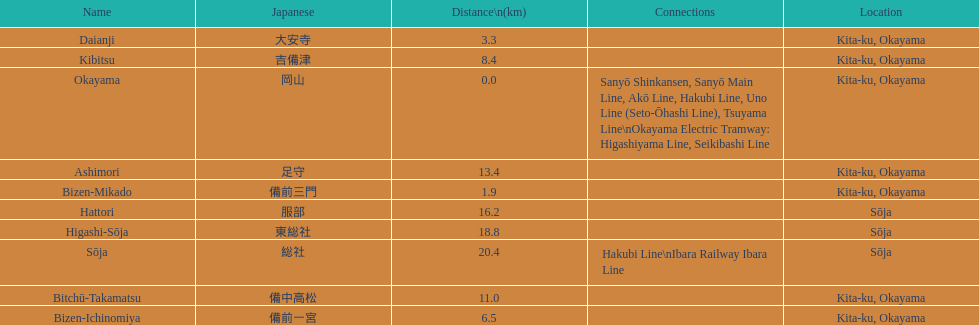Name only the stations that have connections to other lines. Okayama, Sōja. 